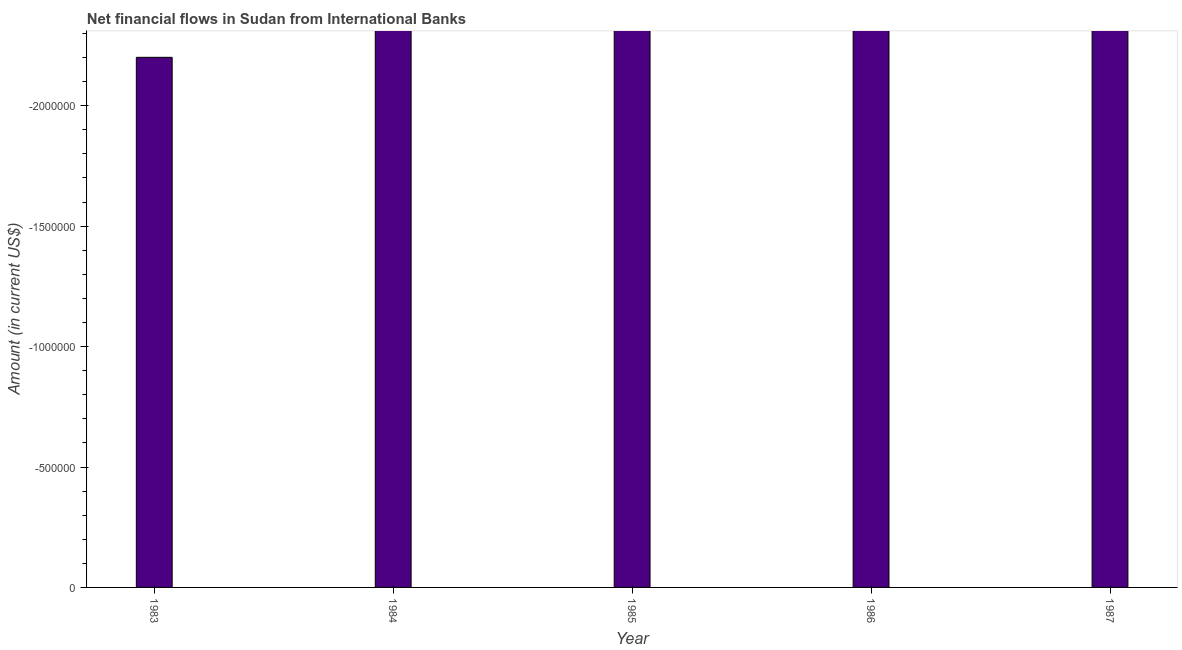Does the graph contain grids?
Provide a succinct answer. No. What is the title of the graph?
Offer a very short reply. Net financial flows in Sudan from International Banks. What is the label or title of the X-axis?
Make the answer very short. Year. What is the net financial flows from ibrd in 1984?
Ensure brevity in your answer.  0. Across all years, what is the minimum net financial flows from ibrd?
Provide a succinct answer. 0. What is the sum of the net financial flows from ibrd?
Your answer should be compact. 0. In how many years, is the net financial flows from ibrd greater than -1900000 US$?
Provide a succinct answer. 0. How many bars are there?
Your answer should be compact. 0. What is the Amount (in current US$) of 1983?
Keep it short and to the point. 0. What is the Amount (in current US$) of 1987?
Make the answer very short. 0. 